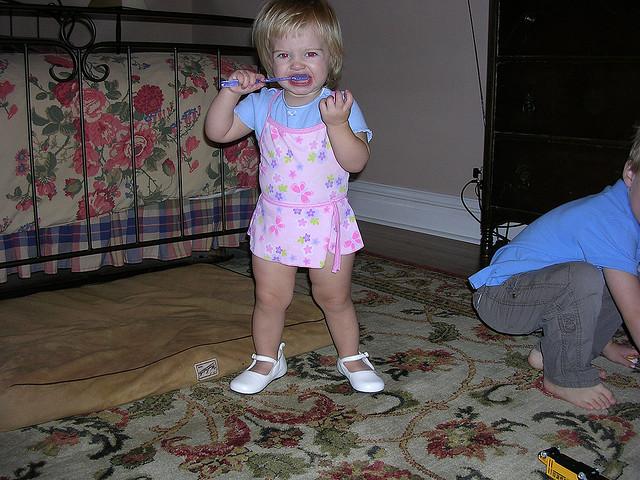Is the person wearing shoes?
Short answer required. Yes. What pattern is the rug?
Quick response, please. Floral. What color is the child's toothbrush?
Write a very short answer. Purple. What color is the girl's shirt?
Write a very short answer. Blue. 